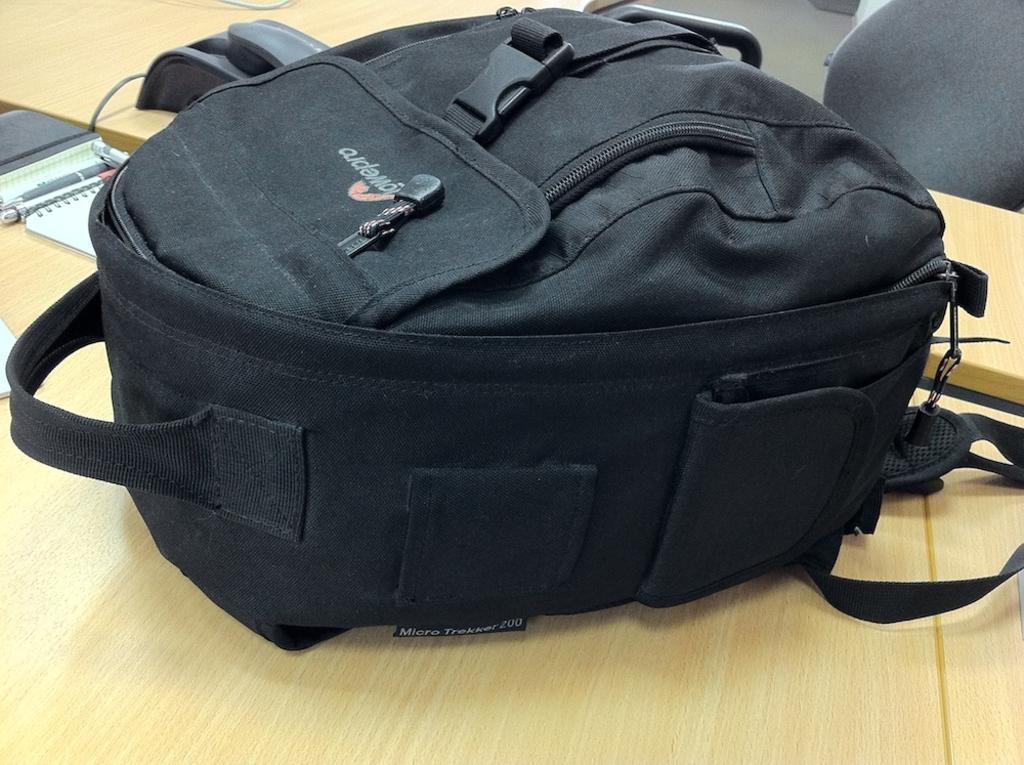Describe this image in one or two sentences. In this picture we can see a bag which is kept on this wooden table. 